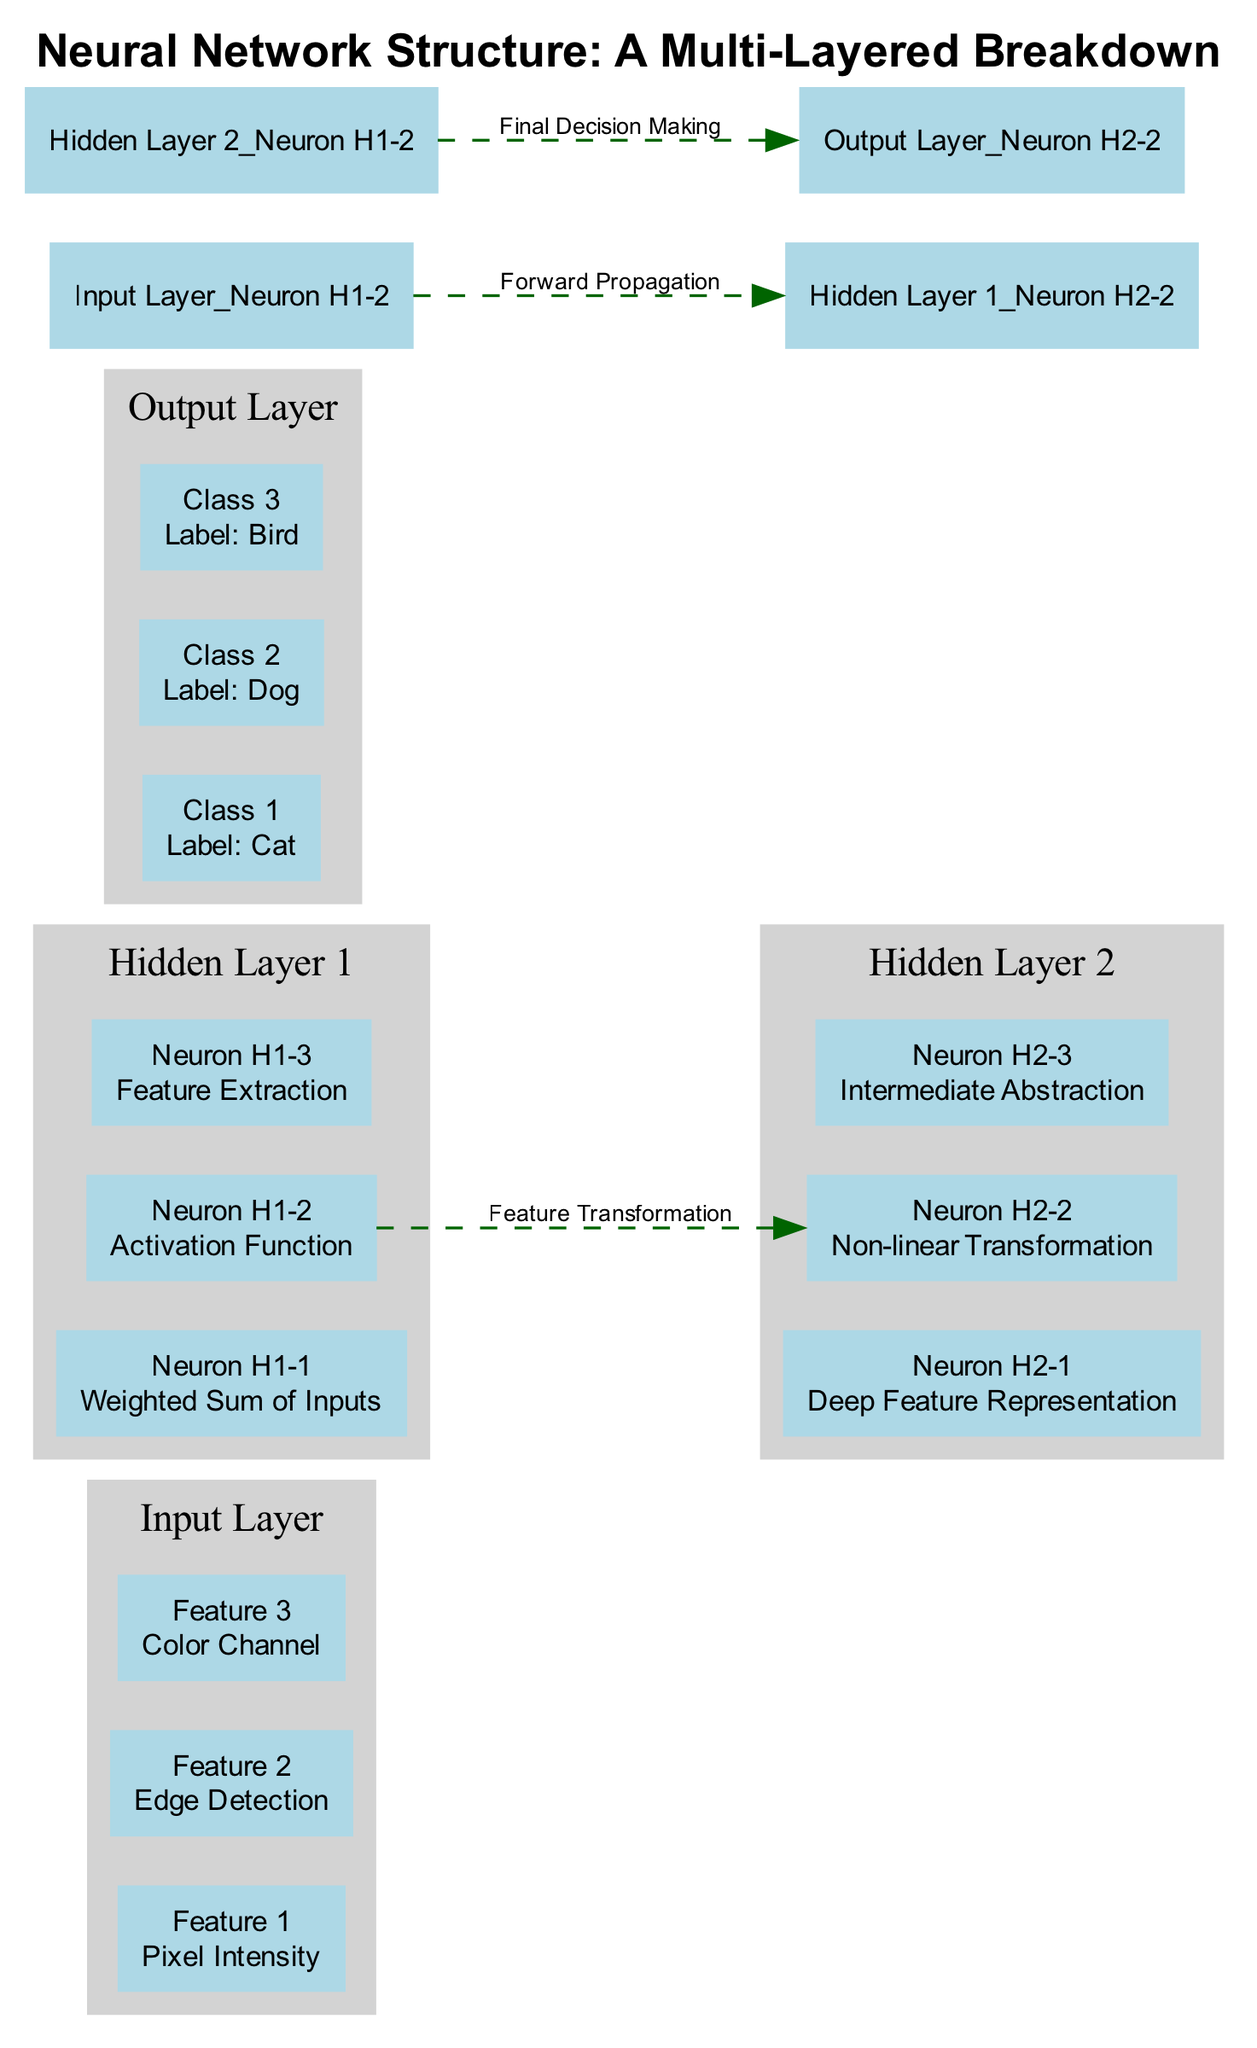What is the first feature in the Input Layer? The first component in the Input Layer is "Feature 1," which is defined as "Pixel Intensity." This information is directly derived from the components listed under the Input Layer in the diagram.
Answer: Pixel Intensity How many neurons are present in Hidden Layer 1? Hidden Layer 1 contains three components: Neuron H1-1, Neuron H1-2, and Neuron H1-3. By counting these components listed in the diagram, we find the total number of neurons is three.
Answer: 3 What transformation occurs between Hidden Layer 1 and Hidden Layer 2? The diagram indicates a connection between Hidden Layer 1 and Hidden Layer 2 labeled "Feature Transformation." This detail highlights the specific type of connection or relationship between these two layers.
Answer: Feature Transformation Which class corresponds to the output label 'Dog'? The "Output Layer" consists of three classes: Class 1 for 'Cat,' Class 2 for 'Dog,' and Class 3 for 'Bird.' By locating the class associated with 'Dog,' it is identified as Class 2.
Answer: Class 2 What is the primary function of Neuron H1-2? Neuron H1-2 in Hidden Layer 1 performs the "Activation Function." This is stated clearly in the description next to Neuron H1-2 within the diagram, denoting its role in processing inputs.
Answer: Activation Function What is the last layer of the neural network? The final layer depicted in the diagram is the "Output Layer," which is the layer that produces the final classifications based on preceding computations. This is explicitly mentioned as the last layer in the sequence.
Answer: Output Layer How many nodes are in Hidden Layer 2? Hidden Layer 2 also features three nodes: Neuron H2-1, Neuron H2-2, and Neuron H2-3. By observing the diagram's components for this layer, we see that it has a total of three nodes.
Answer: 3 Which connection describes the flow from Hidden Layer 2 to the Output Layer? The connection between Hidden Layer 2 and the Output Layer is described as "Final Decision Making." This labeling indicates how the information is processed in this specific stage of the neural network.
Answer: Final Decision Making Which node in Hidden Layer 1 is responsible for weighted input calculations? Neuron H1-1 is described as "Weighted Sum of Inputs," indicating its primary role in the transformations that take place within Hidden Layer 1. This information is explicitly provided in the description of Neuron H1-1.
Answer: Neuron H1-1 